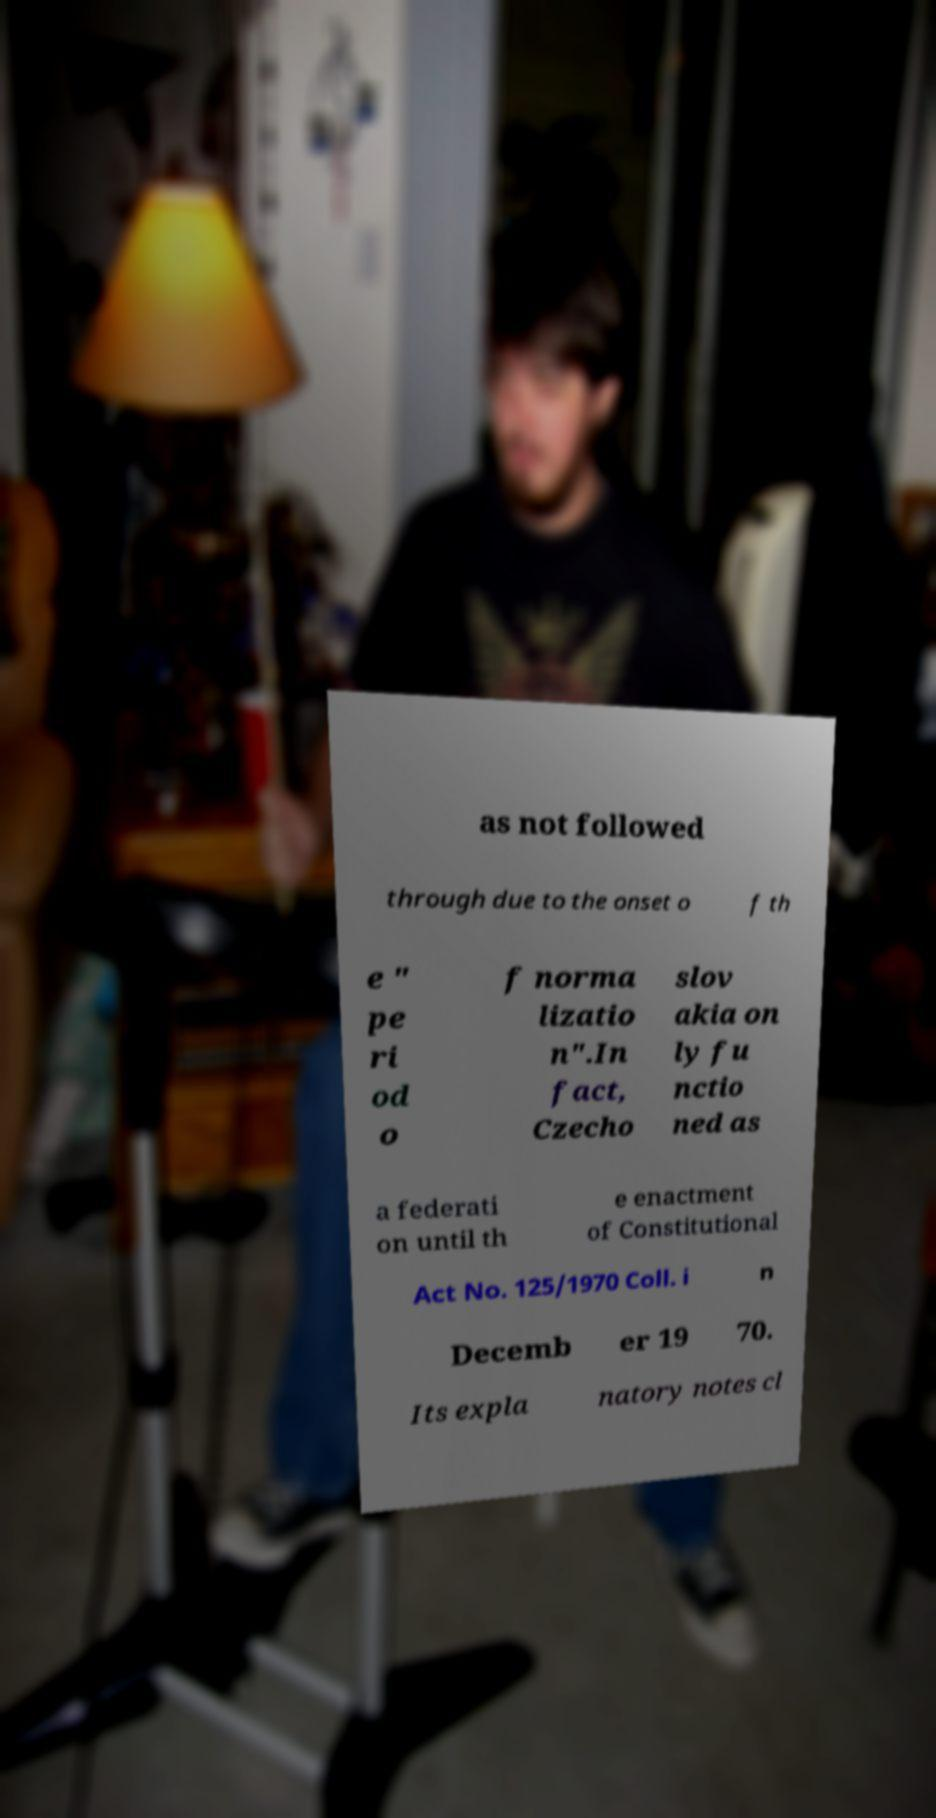Can you accurately transcribe the text from the provided image for me? as not followed through due to the onset o f th e " pe ri od o f norma lizatio n".In fact, Czecho slov akia on ly fu nctio ned as a federati on until th e enactment of Constitutional Act No. 125/1970 Coll. i n Decemb er 19 70. Its expla natory notes cl 